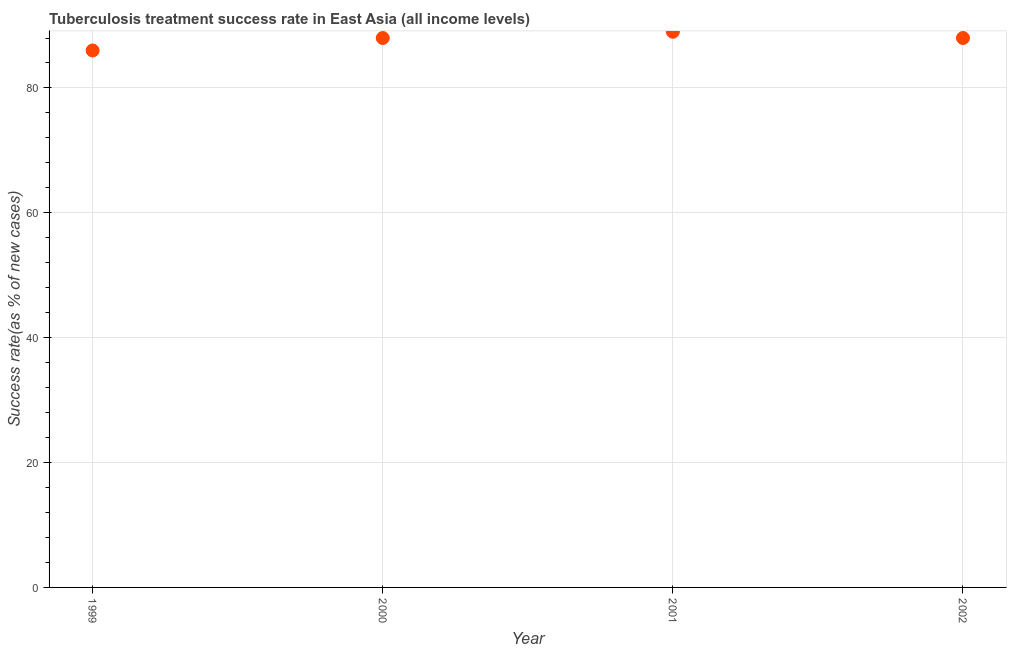What is the tuberculosis treatment success rate in 2000?
Your answer should be compact. 88. Across all years, what is the maximum tuberculosis treatment success rate?
Offer a very short reply. 89. Across all years, what is the minimum tuberculosis treatment success rate?
Offer a very short reply. 86. What is the sum of the tuberculosis treatment success rate?
Keep it short and to the point. 351. What is the difference between the tuberculosis treatment success rate in 2000 and 2001?
Provide a succinct answer. -1. What is the average tuberculosis treatment success rate per year?
Make the answer very short. 87.75. What is the median tuberculosis treatment success rate?
Make the answer very short. 88. In how many years, is the tuberculosis treatment success rate greater than 76 %?
Ensure brevity in your answer.  4. Do a majority of the years between 1999 and 2002 (inclusive) have tuberculosis treatment success rate greater than 60 %?
Provide a short and direct response. Yes. What is the ratio of the tuberculosis treatment success rate in 2000 to that in 2002?
Make the answer very short. 1. Is the sum of the tuberculosis treatment success rate in 1999 and 2002 greater than the maximum tuberculosis treatment success rate across all years?
Your response must be concise. Yes. What is the difference between the highest and the lowest tuberculosis treatment success rate?
Offer a terse response. 3. In how many years, is the tuberculosis treatment success rate greater than the average tuberculosis treatment success rate taken over all years?
Keep it short and to the point. 3. How many years are there in the graph?
Your response must be concise. 4. Are the values on the major ticks of Y-axis written in scientific E-notation?
Provide a short and direct response. No. Does the graph contain any zero values?
Offer a very short reply. No. Does the graph contain grids?
Offer a terse response. Yes. What is the title of the graph?
Make the answer very short. Tuberculosis treatment success rate in East Asia (all income levels). What is the label or title of the X-axis?
Offer a terse response. Year. What is the label or title of the Y-axis?
Make the answer very short. Success rate(as % of new cases). What is the Success rate(as % of new cases) in 2000?
Make the answer very short. 88. What is the Success rate(as % of new cases) in 2001?
Ensure brevity in your answer.  89. What is the Success rate(as % of new cases) in 2002?
Provide a succinct answer. 88. What is the difference between the Success rate(as % of new cases) in 2000 and 2001?
Your answer should be compact. -1. What is the difference between the Success rate(as % of new cases) in 2000 and 2002?
Make the answer very short. 0. What is the difference between the Success rate(as % of new cases) in 2001 and 2002?
Your answer should be compact. 1. What is the ratio of the Success rate(as % of new cases) in 1999 to that in 2002?
Provide a short and direct response. 0.98. What is the ratio of the Success rate(as % of new cases) in 2000 to that in 2001?
Your answer should be very brief. 0.99. What is the ratio of the Success rate(as % of new cases) in 2000 to that in 2002?
Provide a short and direct response. 1. What is the ratio of the Success rate(as % of new cases) in 2001 to that in 2002?
Your answer should be very brief. 1.01. 